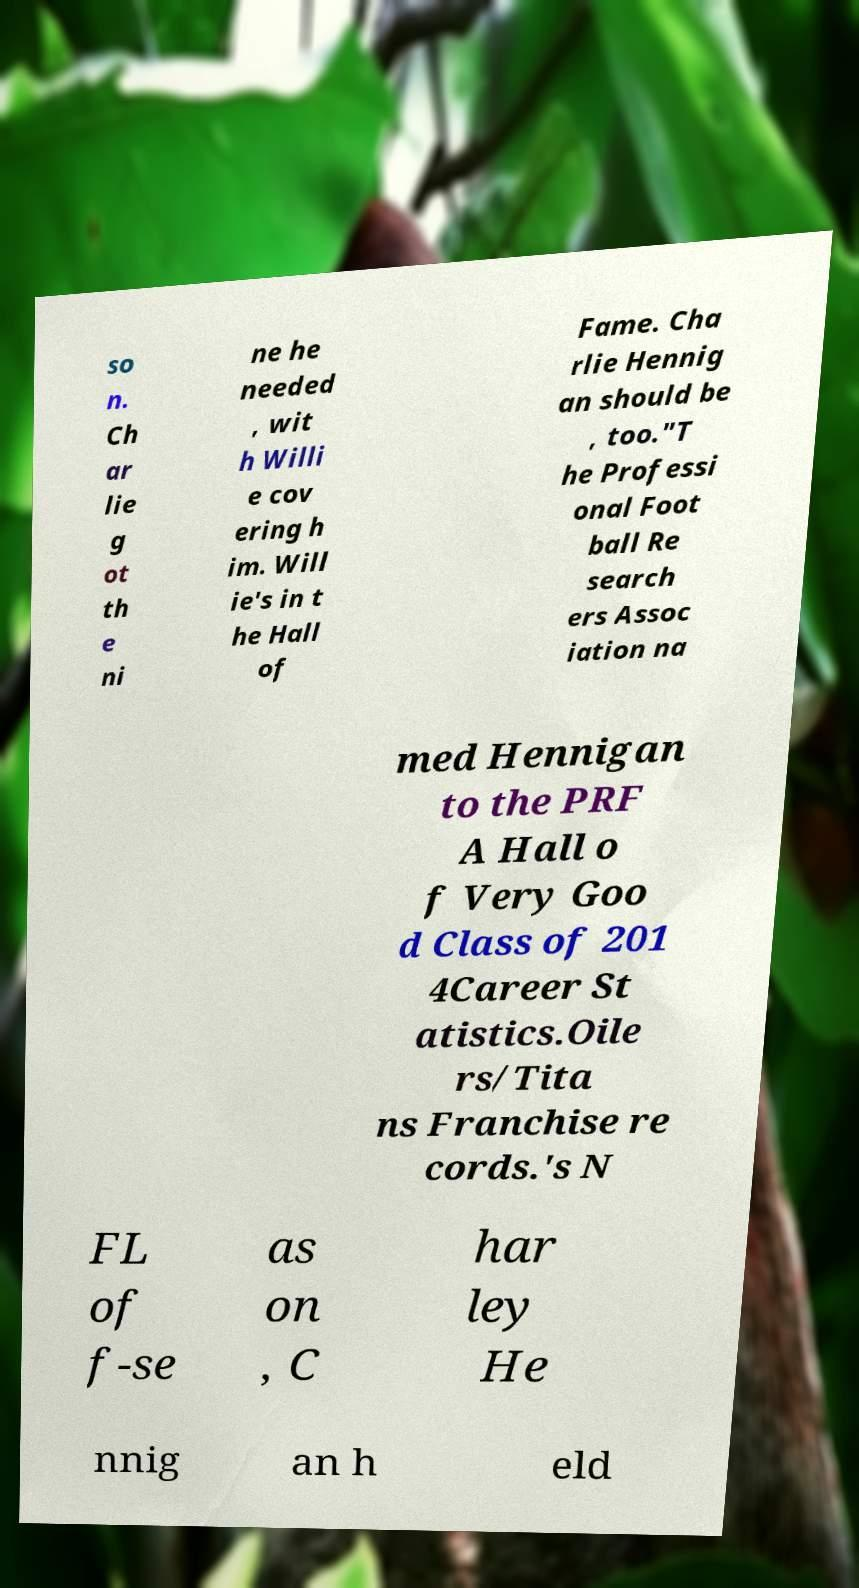Could you assist in decoding the text presented in this image and type it out clearly? so n. Ch ar lie g ot th e ni ne he needed , wit h Willi e cov ering h im. Will ie's in t he Hall of Fame. Cha rlie Hennig an should be , too."T he Professi onal Foot ball Re search ers Assoc iation na med Hennigan to the PRF A Hall o f Very Goo d Class of 201 4Career St atistics.Oile rs/Tita ns Franchise re cords.'s N FL of f-se as on , C har ley He nnig an h eld 